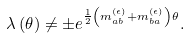Convert formula to latex. <formula><loc_0><loc_0><loc_500><loc_500>\lambda \left ( \theta \right ) \neq \pm e ^ { \frac { 1 } { 2 } \left ( m _ { a b } ^ { ( \epsilon ) } + m _ { b a } ^ { ( \epsilon ) } \right ) \theta } .</formula> 